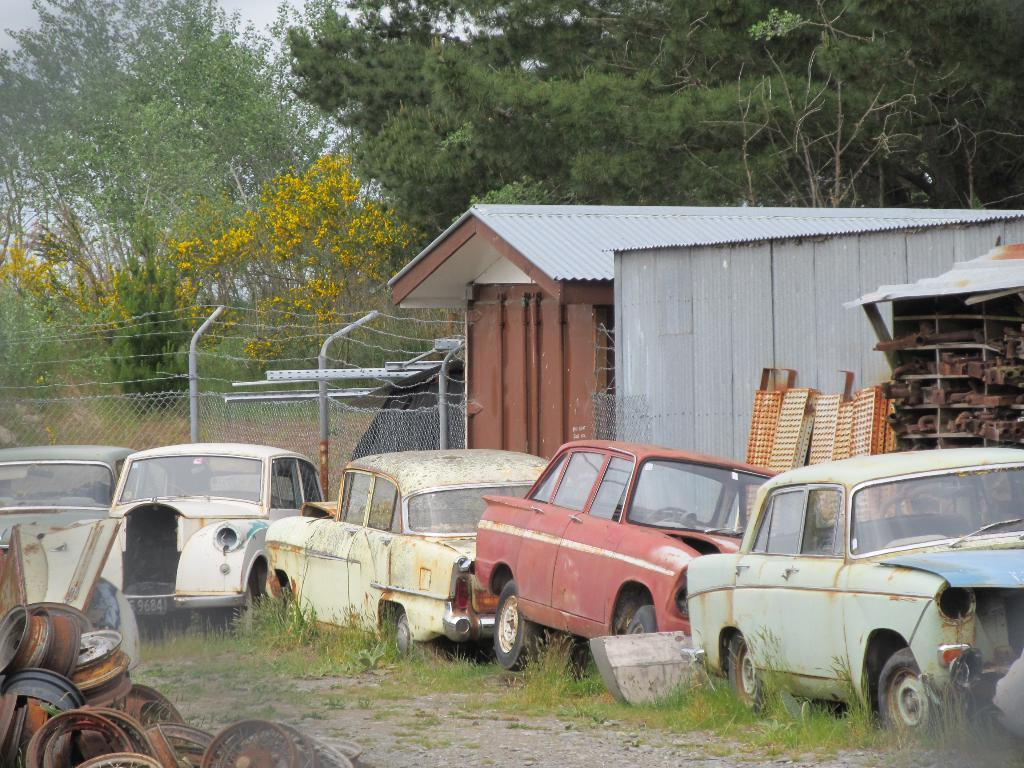What type of vehicles are in the middle of the image? There are old cars in the middle of the image. What structures can be seen on the right side of the image? There are iron sheds on the right side of the image. What type of natural elements are visible at the back side of the image? There are trees visible at the back side of the image. How many cakes are being lined up for the laugh in the image? There are no cakes or any indication of laughter in the image. 